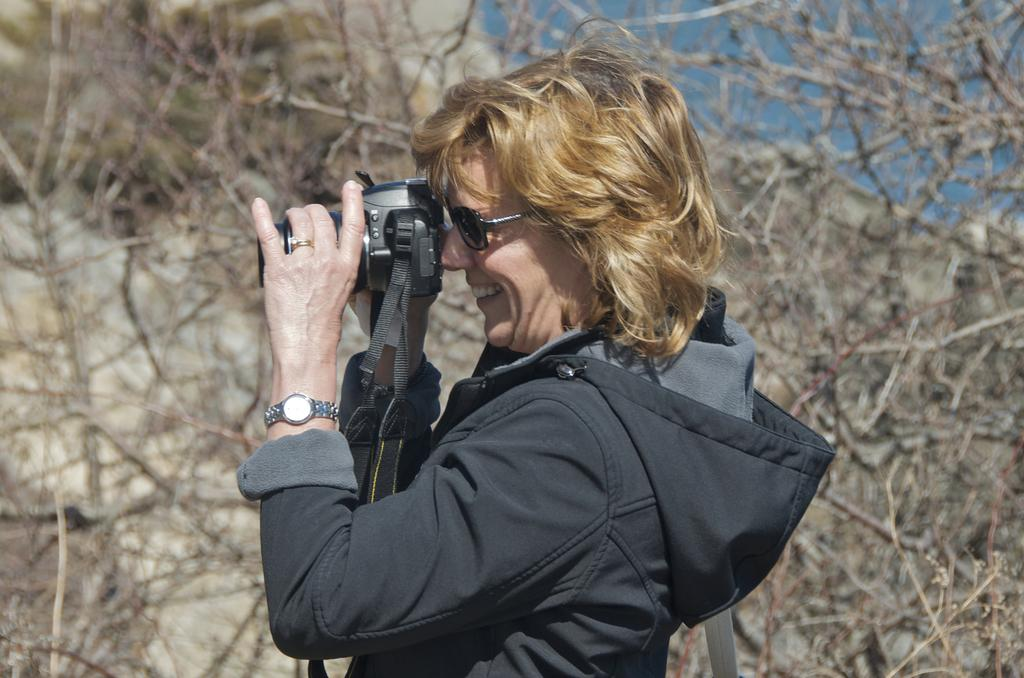Who is the main subject in the image? There is a woman in the image. What is the woman wearing? The woman is wearing a jacket, a watch, and shades. What expression does the woman have? The woman is smiling. What is the woman holding in the image? The woman is holding a camera. What type of cheese is the woman eating in the image? There is no cheese present in the image; the woman is holding a camera. How many nails can be seen in the image? There are no nails visible in the image. 